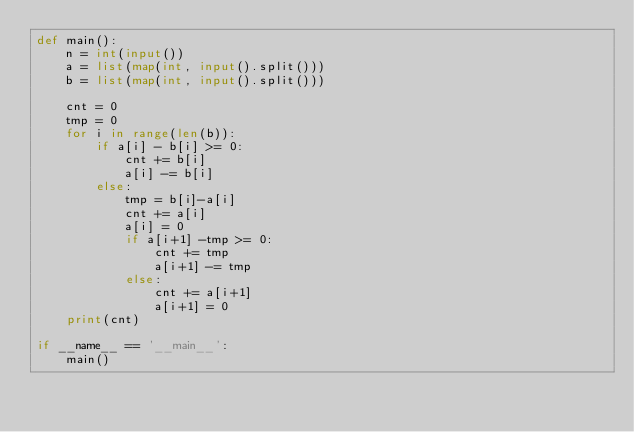<code> <loc_0><loc_0><loc_500><loc_500><_Python_>def main():
    n = int(input())
    a = list(map(int, input().split()))
    b = list(map(int, input().split()))

    cnt = 0
    tmp = 0
    for i in range(len(b)):
        if a[i] - b[i] >= 0:
            cnt += b[i]
            a[i] -= b[i]
        else:
            tmp = b[i]-a[i]
            cnt += a[i]
            a[i] = 0
            if a[i+1] -tmp >= 0:
                cnt += tmp
                a[i+1] -= tmp
            else:
                cnt += a[i+1]
                a[i+1] = 0
    print(cnt)

if __name__ == '__main__':
    main()
</code> 